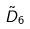<formula> <loc_0><loc_0><loc_500><loc_500>\tilde { D } _ { 6 }</formula> 